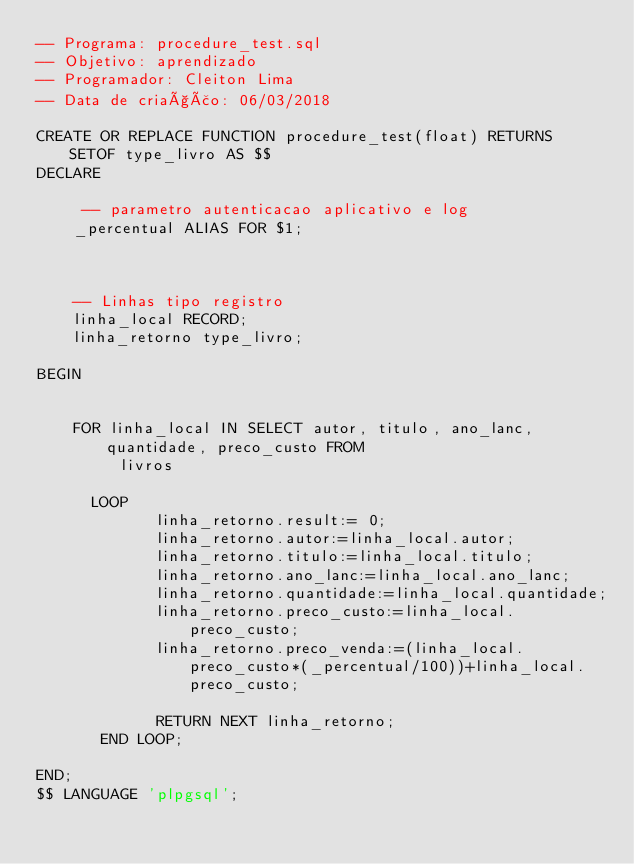Convert code to text. <code><loc_0><loc_0><loc_500><loc_500><_SQL_>-- Programa: procedure_test.sql
-- Objetivo: aprendizado
-- Programador: Cleiton Lima
-- Data de criação: 06/03/2018

CREATE OR REPLACE FUNCTION procedure_test(float) RETURNS  SETOF type_livro AS $$
DECLARE

	 -- parametro autenticacao aplicativo e log
    _percentual ALIAS FOR $1;
    
    

	-- Linhas tipo registro
    linha_local RECORD;
    linha_retorno type_livro;

BEGIN
	

	FOR linha_local IN SELECT autor, titulo, ano_lanc, quantidade, preco_custo FROM 
         livros
     
      LOOP
             linha_retorno.result:= 0;
             linha_retorno.autor:=linha_local.autor;
             linha_retorno.titulo:=linha_local.titulo;
             linha_retorno.ano_lanc:=linha_local.ano_lanc;
             linha_retorno.quantidade:=linha_local.quantidade;
             linha_retorno.preco_custo:=linha_local.preco_custo;
             linha_retorno.preco_venda:=(linha_local.preco_custo*(_percentual/100))+linha_local.preco_custo;

             RETURN NEXT linha_retorno;
       END LOOP;

END;
$$ LANGUAGE 'plpgsql';


</code> 